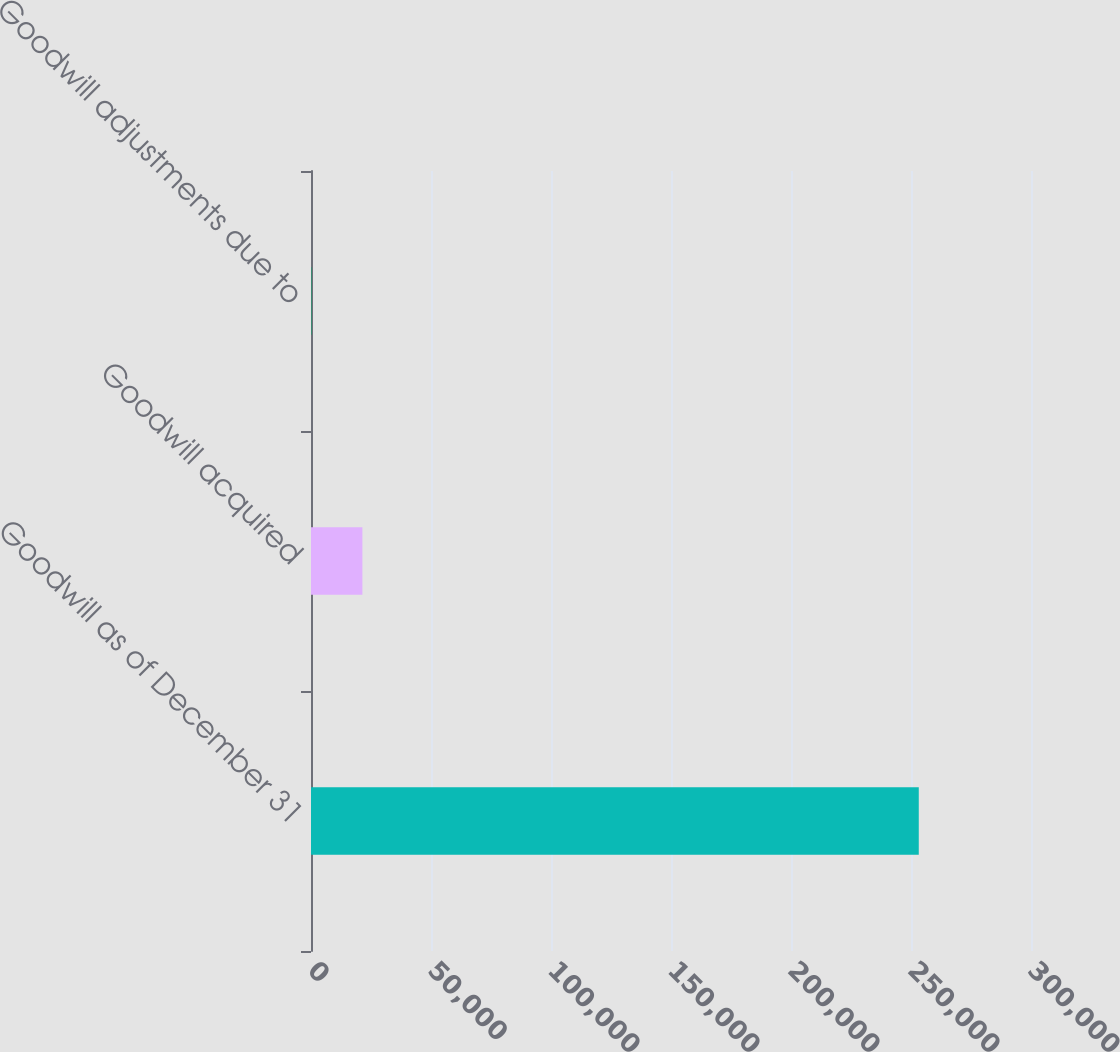Convert chart to OTSL. <chart><loc_0><loc_0><loc_500><loc_500><bar_chart><fcel>Goodwill as of December 31<fcel>Goodwill acquired<fcel>Goodwill adjustments due to<nl><fcel>253237<fcel>21417.8<fcel>189<nl></chart> 